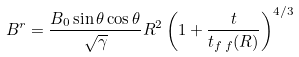<formula> <loc_0><loc_0><loc_500><loc_500>B ^ { r } = \frac { B _ { 0 } \sin \theta \cos \theta } { \sqrt { \gamma } } R ^ { 2 } \left ( 1 + \frac { t } { t _ { f \, f } ( R ) } \right ) ^ { 4 / 3 }</formula> 